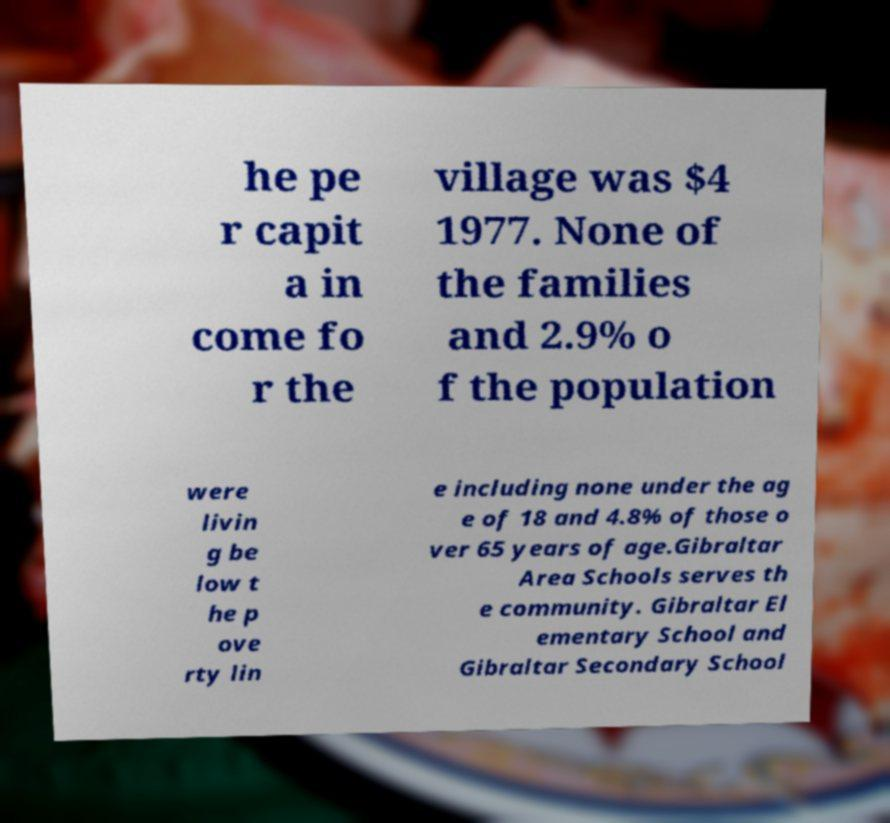Could you extract and type out the text from this image? he pe r capit a in come fo r the village was $4 1977. None of the families and 2.9% o f the population were livin g be low t he p ove rty lin e including none under the ag e of 18 and 4.8% of those o ver 65 years of age.Gibraltar Area Schools serves th e community. Gibraltar El ementary School and Gibraltar Secondary School 